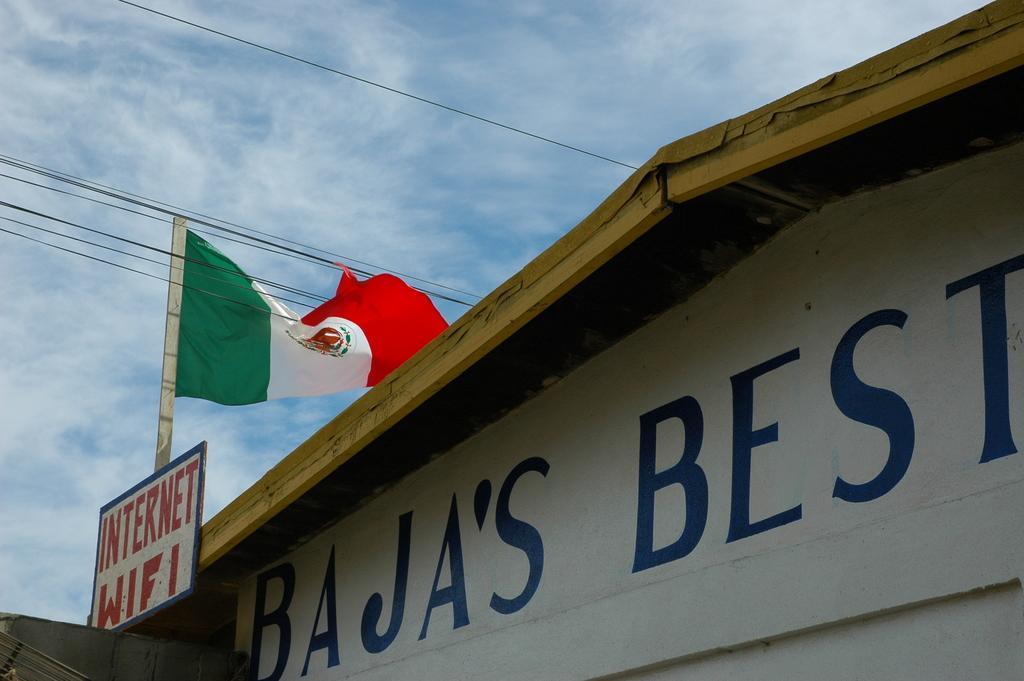Describe this image in one or two sentences. This is the picture of a building. In this image there is a building and there is a text on the building. There is a board on the building and there is a text on the board and there is a flag on the building. At the top there is sky and there are clouds and wires. 